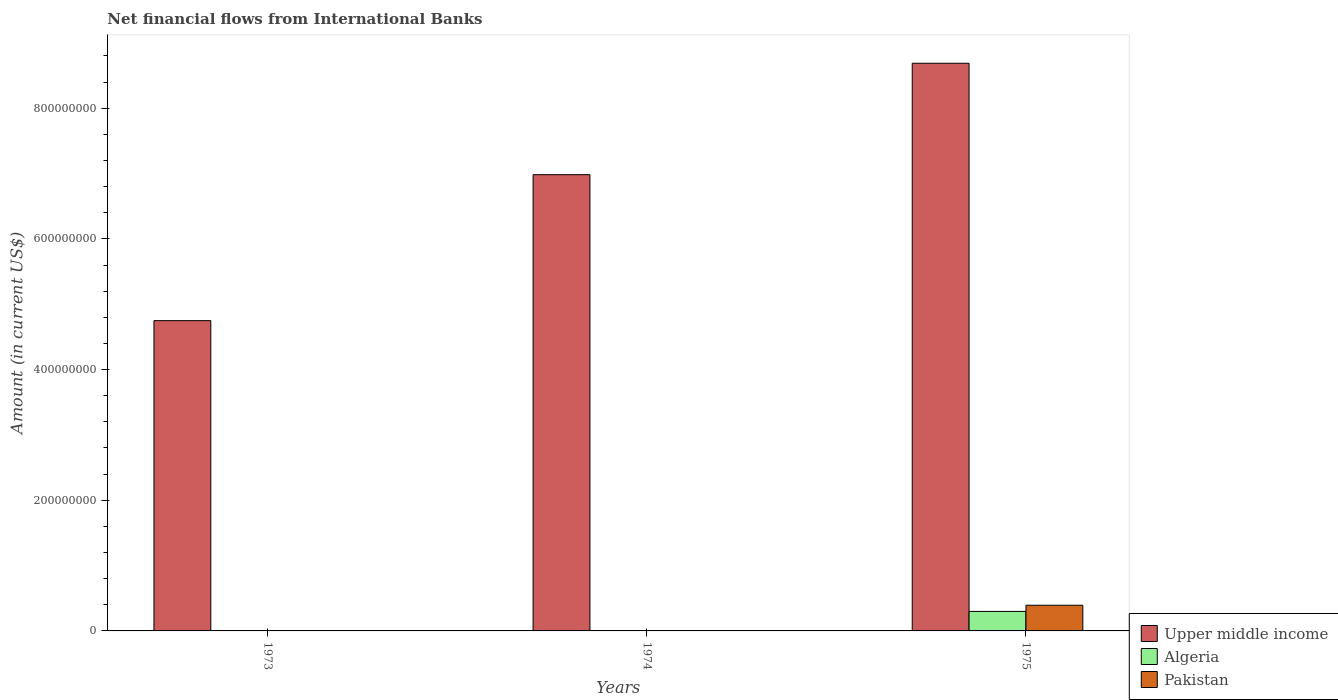Are the number of bars per tick equal to the number of legend labels?
Ensure brevity in your answer.  No. How many bars are there on the 3rd tick from the left?
Your answer should be compact. 3. What is the label of the 3rd group of bars from the left?
Offer a terse response. 1975. In how many cases, is the number of bars for a given year not equal to the number of legend labels?
Your answer should be very brief. 2. What is the net financial aid flows in Upper middle income in 1975?
Ensure brevity in your answer.  8.69e+08. Across all years, what is the maximum net financial aid flows in Upper middle income?
Offer a very short reply. 8.69e+08. In which year was the net financial aid flows in Algeria maximum?
Your response must be concise. 1975. What is the total net financial aid flows in Pakistan in the graph?
Ensure brevity in your answer.  3.93e+07. What is the difference between the net financial aid flows in Upper middle income in 1973 and that in 1975?
Offer a very short reply. -3.94e+08. What is the difference between the net financial aid flows in Algeria in 1973 and the net financial aid flows in Upper middle income in 1974?
Your answer should be very brief. -6.98e+08. What is the average net financial aid flows in Algeria per year?
Give a very brief answer. 9.95e+06. In the year 1975, what is the difference between the net financial aid flows in Pakistan and net financial aid flows in Upper middle income?
Provide a succinct answer. -8.29e+08. In how many years, is the net financial aid flows in Pakistan greater than 320000000 US$?
Give a very brief answer. 0. What is the ratio of the net financial aid flows in Upper middle income in 1974 to that in 1975?
Offer a terse response. 0.8. What is the difference between the highest and the second highest net financial aid flows in Upper middle income?
Make the answer very short. 1.71e+08. What is the difference between the highest and the lowest net financial aid flows in Upper middle income?
Your response must be concise. 3.94e+08. Is it the case that in every year, the sum of the net financial aid flows in Upper middle income and net financial aid flows in Pakistan is greater than the net financial aid flows in Algeria?
Your answer should be very brief. Yes. How many bars are there?
Offer a very short reply. 5. What is the difference between two consecutive major ticks on the Y-axis?
Provide a succinct answer. 2.00e+08. Are the values on the major ticks of Y-axis written in scientific E-notation?
Make the answer very short. No. Does the graph contain any zero values?
Keep it short and to the point. Yes. Does the graph contain grids?
Provide a short and direct response. No. What is the title of the graph?
Offer a terse response. Net financial flows from International Banks. What is the label or title of the X-axis?
Keep it short and to the point. Years. What is the label or title of the Y-axis?
Your response must be concise. Amount (in current US$). What is the Amount (in current US$) of Upper middle income in 1973?
Make the answer very short. 4.75e+08. What is the Amount (in current US$) of Upper middle income in 1974?
Give a very brief answer. 6.98e+08. What is the Amount (in current US$) in Upper middle income in 1975?
Ensure brevity in your answer.  8.69e+08. What is the Amount (in current US$) of Algeria in 1975?
Provide a short and direct response. 2.99e+07. What is the Amount (in current US$) of Pakistan in 1975?
Ensure brevity in your answer.  3.93e+07. Across all years, what is the maximum Amount (in current US$) in Upper middle income?
Your response must be concise. 8.69e+08. Across all years, what is the maximum Amount (in current US$) of Algeria?
Provide a succinct answer. 2.99e+07. Across all years, what is the maximum Amount (in current US$) in Pakistan?
Make the answer very short. 3.93e+07. Across all years, what is the minimum Amount (in current US$) of Upper middle income?
Provide a short and direct response. 4.75e+08. Across all years, what is the minimum Amount (in current US$) in Algeria?
Give a very brief answer. 0. Across all years, what is the minimum Amount (in current US$) of Pakistan?
Give a very brief answer. 0. What is the total Amount (in current US$) of Upper middle income in the graph?
Provide a short and direct response. 2.04e+09. What is the total Amount (in current US$) in Algeria in the graph?
Provide a succinct answer. 2.99e+07. What is the total Amount (in current US$) of Pakistan in the graph?
Your response must be concise. 3.93e+07. What is the difference between the Amount (in current US$) of Upper middle income in 1973 and that in 1974?
Offer a very short reply. -2.23e+08. What is the difference between the Amount (in current US$) in Upper middle income in 1973 and that in 1975?
Provide a succinct answer. -3.94e+08. What is the difference between the Amount (in current US$) in Upper middle income in 1974 and that in 1975?
Ensure brevity in your answer.  -1.71e+08. What is the difference between the Amount (in current US$) in Upper middle income in 1973 and the Amount (in current US$) in Algeria in 1975?
Your answer should be very brief. 4.45e+08. What is the difference between the Amount (in current US$) of Upper middle income in 1973 and the Amount (in current US$) of Pakistan in 1975?
Offer a very short reply. 4.36e+08. What is the difference between the Amount (in current US$) of Upper middle income in 1974 and the Amount (in current US$) of Algeria in 1975?
Your answer should be very brief. 6.68e+08. What is the difference between the Amount (in current US$) in Upper middle income in 1974 and the Amount (in current US$) in Pakistan in 1975?
Make the answer very short. 6.59e+08. What is the average Amount (in current US$) in Upper middle income per year?
Keep it short and to the point. 6.81e+08. What is the average Amount (in current US$) of Algeria per year?
Your response must be concise. 9.95e+06. What is the average Amount (in current US$) of Pakistan per year?
Provide a succinct answer. 1.31e+07. In the year 1975, what is the difference between the Amount (in current US$) of Upper middle income and Amount (in current US$) of Algeria?
Offer a very short reply. 8.39e+08. In the year 1975, what is the difference between the Amount (in current US$) of Upper middle income and Amount (in current US$) of Pakistan?
Offer a terse response. 8.29e+08. In the year 1975, what is the difference between the Amount (in current US$) of Algeria and Amount (in current US$) of Pakistan?
Keep it short and to the point. -9.45e+06. What is the ratio of the Amount (in current US$) in Upper middle income in 1973 to that in 1974?
Your response must be concise. 0.68. What is the ratio of the Amount (in current US$) in Upper middle income in 1973 to that in 1975?
Provide a succinct answer. 0.55. What is the ratio of the Amount (in current US$) of Upper middle income in 1974 to that in 1975?
Provide a short and direct response. 0.8. What is the difference between the highest and the second highest Amount (in current US$) in Upper middle income?
Your response must be concise. 1.71e+08. What is the difference between the highest and the lowest Amount (in current US$) of Upper middle income?
Make the answer very short. 3.94e+08. What is the difference between the highest and the lowest Amount (in current US$) in Algeria?
Provide a short and direct response. 2.99e+07. What is the difference between the highest and the lowest Amount (in current US$) of Pakistan?
Provide a succinct answer. 3.93e+07. 